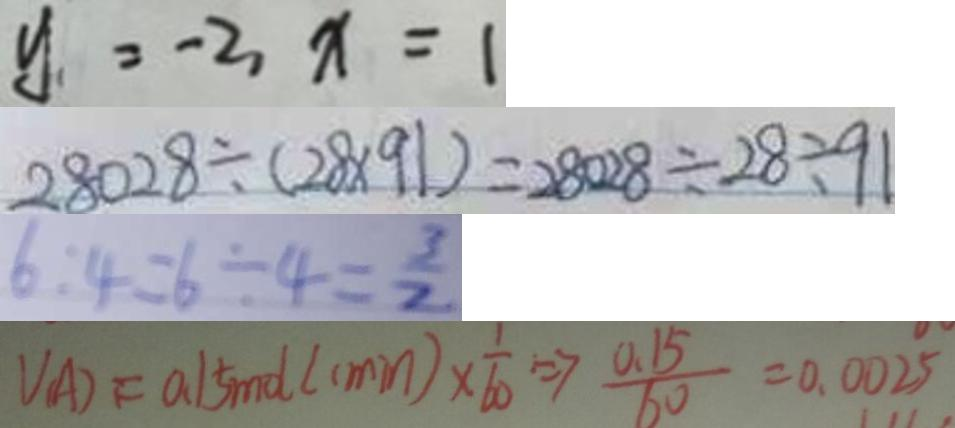Convert formula to latex. <formula><loc_0><loc_0><loc_500><loc_500>y = - 2 , x = 1 
 2 8 0 2 8 \div ( 2 8 \times 9 1 ) = 2 8 0 2 8 \div 2 8 \div 9 1 
 6 : 4 = 6 \div 4 = \frac { 3 } { 2 } 
 V _ { ( A ) } = 0 . 1 5 m d ( c \min ) \times \frac { 1 } { 6 0 } \Rightarrow \frac { 0 . 1 5 } { 6 0 } = 0 . 0 0 2 5</formula> 